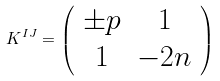<formula> <loc_0><loc_0><loc_500><loc_500>K ^ { I J } = \left ( \begin{array} { c c } \pm p & 1 \\ 1 & - 2 n \end{array} \right )</formula> 